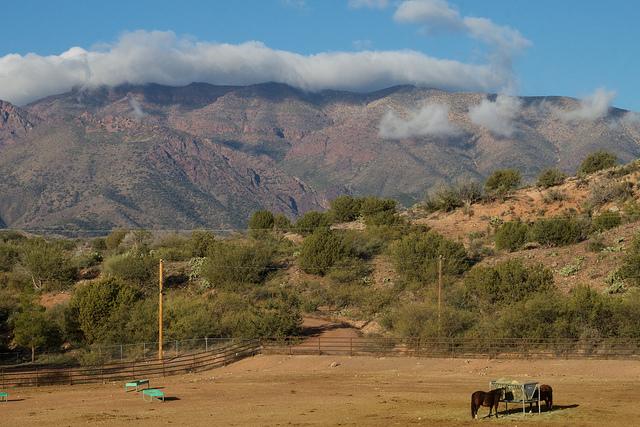Does the horse appear to be in an enclosed pasture?
Concise answer only. Yes. Could this be in Antarctica?
Be succinct. No. What is on top of the mountain?
Concise answer only. Clouds. Is this being taken in the desert?
Give a very brief answer. Yes. Is this a natural habitat for elephants?
Answer briefly. No. What animal is shown?
Be succinct. Horse. 